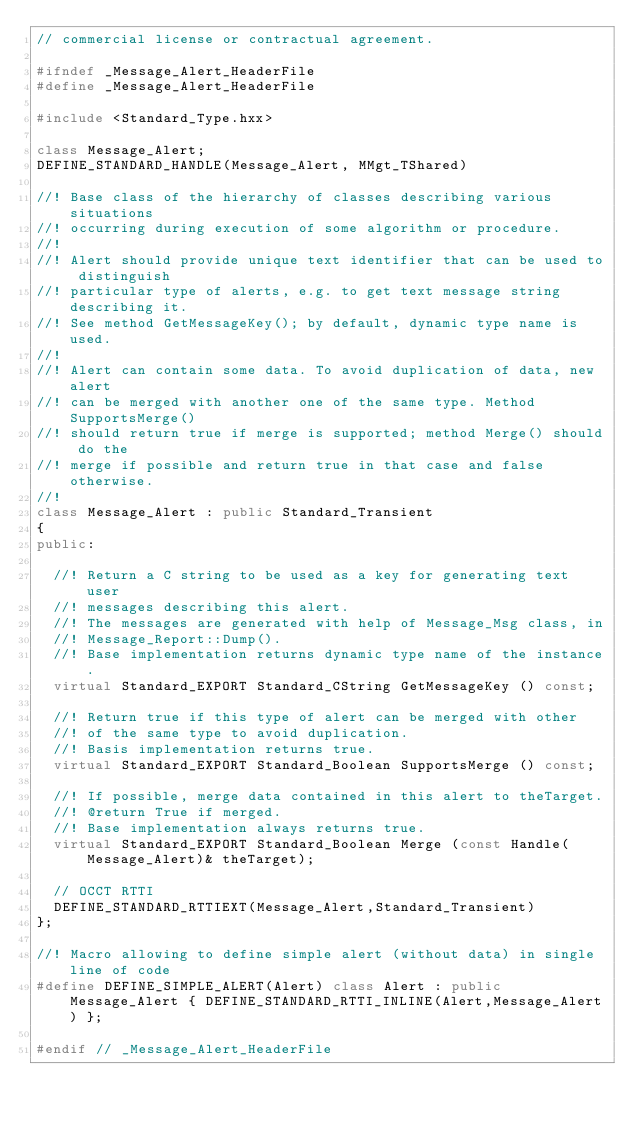Convert code to text. <code><loc_0><loc_0><loc_500><loc_500><_C++_>// commercial license or contractual agreement.

#ifndef _Message_Alert_HeaderFile
#define _Message_Alert_HeaderFile

#include <Standard_Type.hxx>

class Message_Alert;
DEFINE_STANDARD_HANDLE(Message_Alert, MMgt_TShared)

//! Base class of the hierarchy of classes describing various situations
//! occurring during execution of some algorithm or procedure.
//!
//! Alert should provide unique text identifier that can be used to distinguish 
//! particular type of alerts, e.g. to get text message string describing it. 
//! See method GetMessageKey(); by default, dynamic type name is used.
//!
//! Alert can contain some data. To avoid duplication of data, new alert
//! can be merged with another one of the same type. Method SupportsMerge() 
//! should return true if merge is supported; method Merge() should do the
//! merge if possible and return true in that case and false otherwise.
//! 
class Message_Alert : public Standard_Transient
{
public:

  //! Return a C string to be used as a key for generating text user 
  //! messages describing this alert.
  //! The messages are generated with help of Message_Msg class, in
  //! Message_Report::Dump().
  //! Base implementation returns dynamic type name of the instance.
  virtual Standard_EXPORT Standard_CString GetMessageKey () const;
  
  //! Return true if this type of alert can be merged with other
  //! of the same type to avoid duplication.
  //! Basis implementation returns true.
  virtual Standard_EXPORT Standard_Boolean SupportsMerge () const;
  
  //! If possible, merge data contained in this alert to theTarget.
  //! @return True if merged.
  //! Base implementation always returns true.
  virtual Standard_EXPORT Standard_Boolean Merge (const Handle(Message_Alert)& theTarget);
  
  // OCCT RTTI
  DEFINE_STANDARD_RTTIEXT(Message_Alert,Standard_Transient)
};

//! Macro allowing to define simple alert (without data) in single line of code
#define DEFINE_SIMPLE_ALERT(Alert) class Alert : public Message_Alert { DEFINE_STANDARD_RTTI_INLINE(Alert,Message_Alert) };

#endif // _Message_Alert_HeaderFile
</code> 